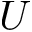Convert formula to latex. <formula><loc_0><loc_0><loc_500><loc_500>U</formula> 